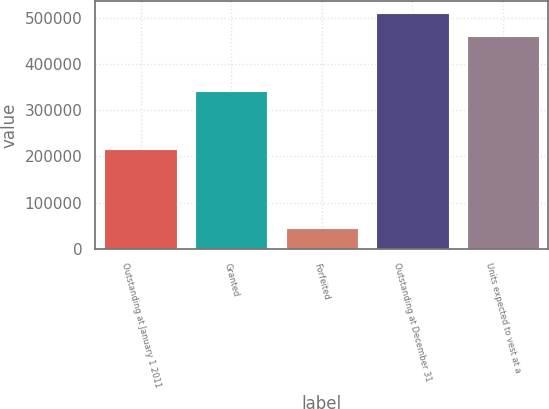<chart> <loc_0><loc_0><loc_500><loc_500><bar_chart><fcel>Outstanding at January 1 2011<fcel>Granted<fcel>Forfeited<fcel>Outstanding at December 31<fcel>Units expected to vest at a<nl><fcel>216251<fcel>340750<fcel>44680<fcel>510681<fcel>459613<nl></chart> 